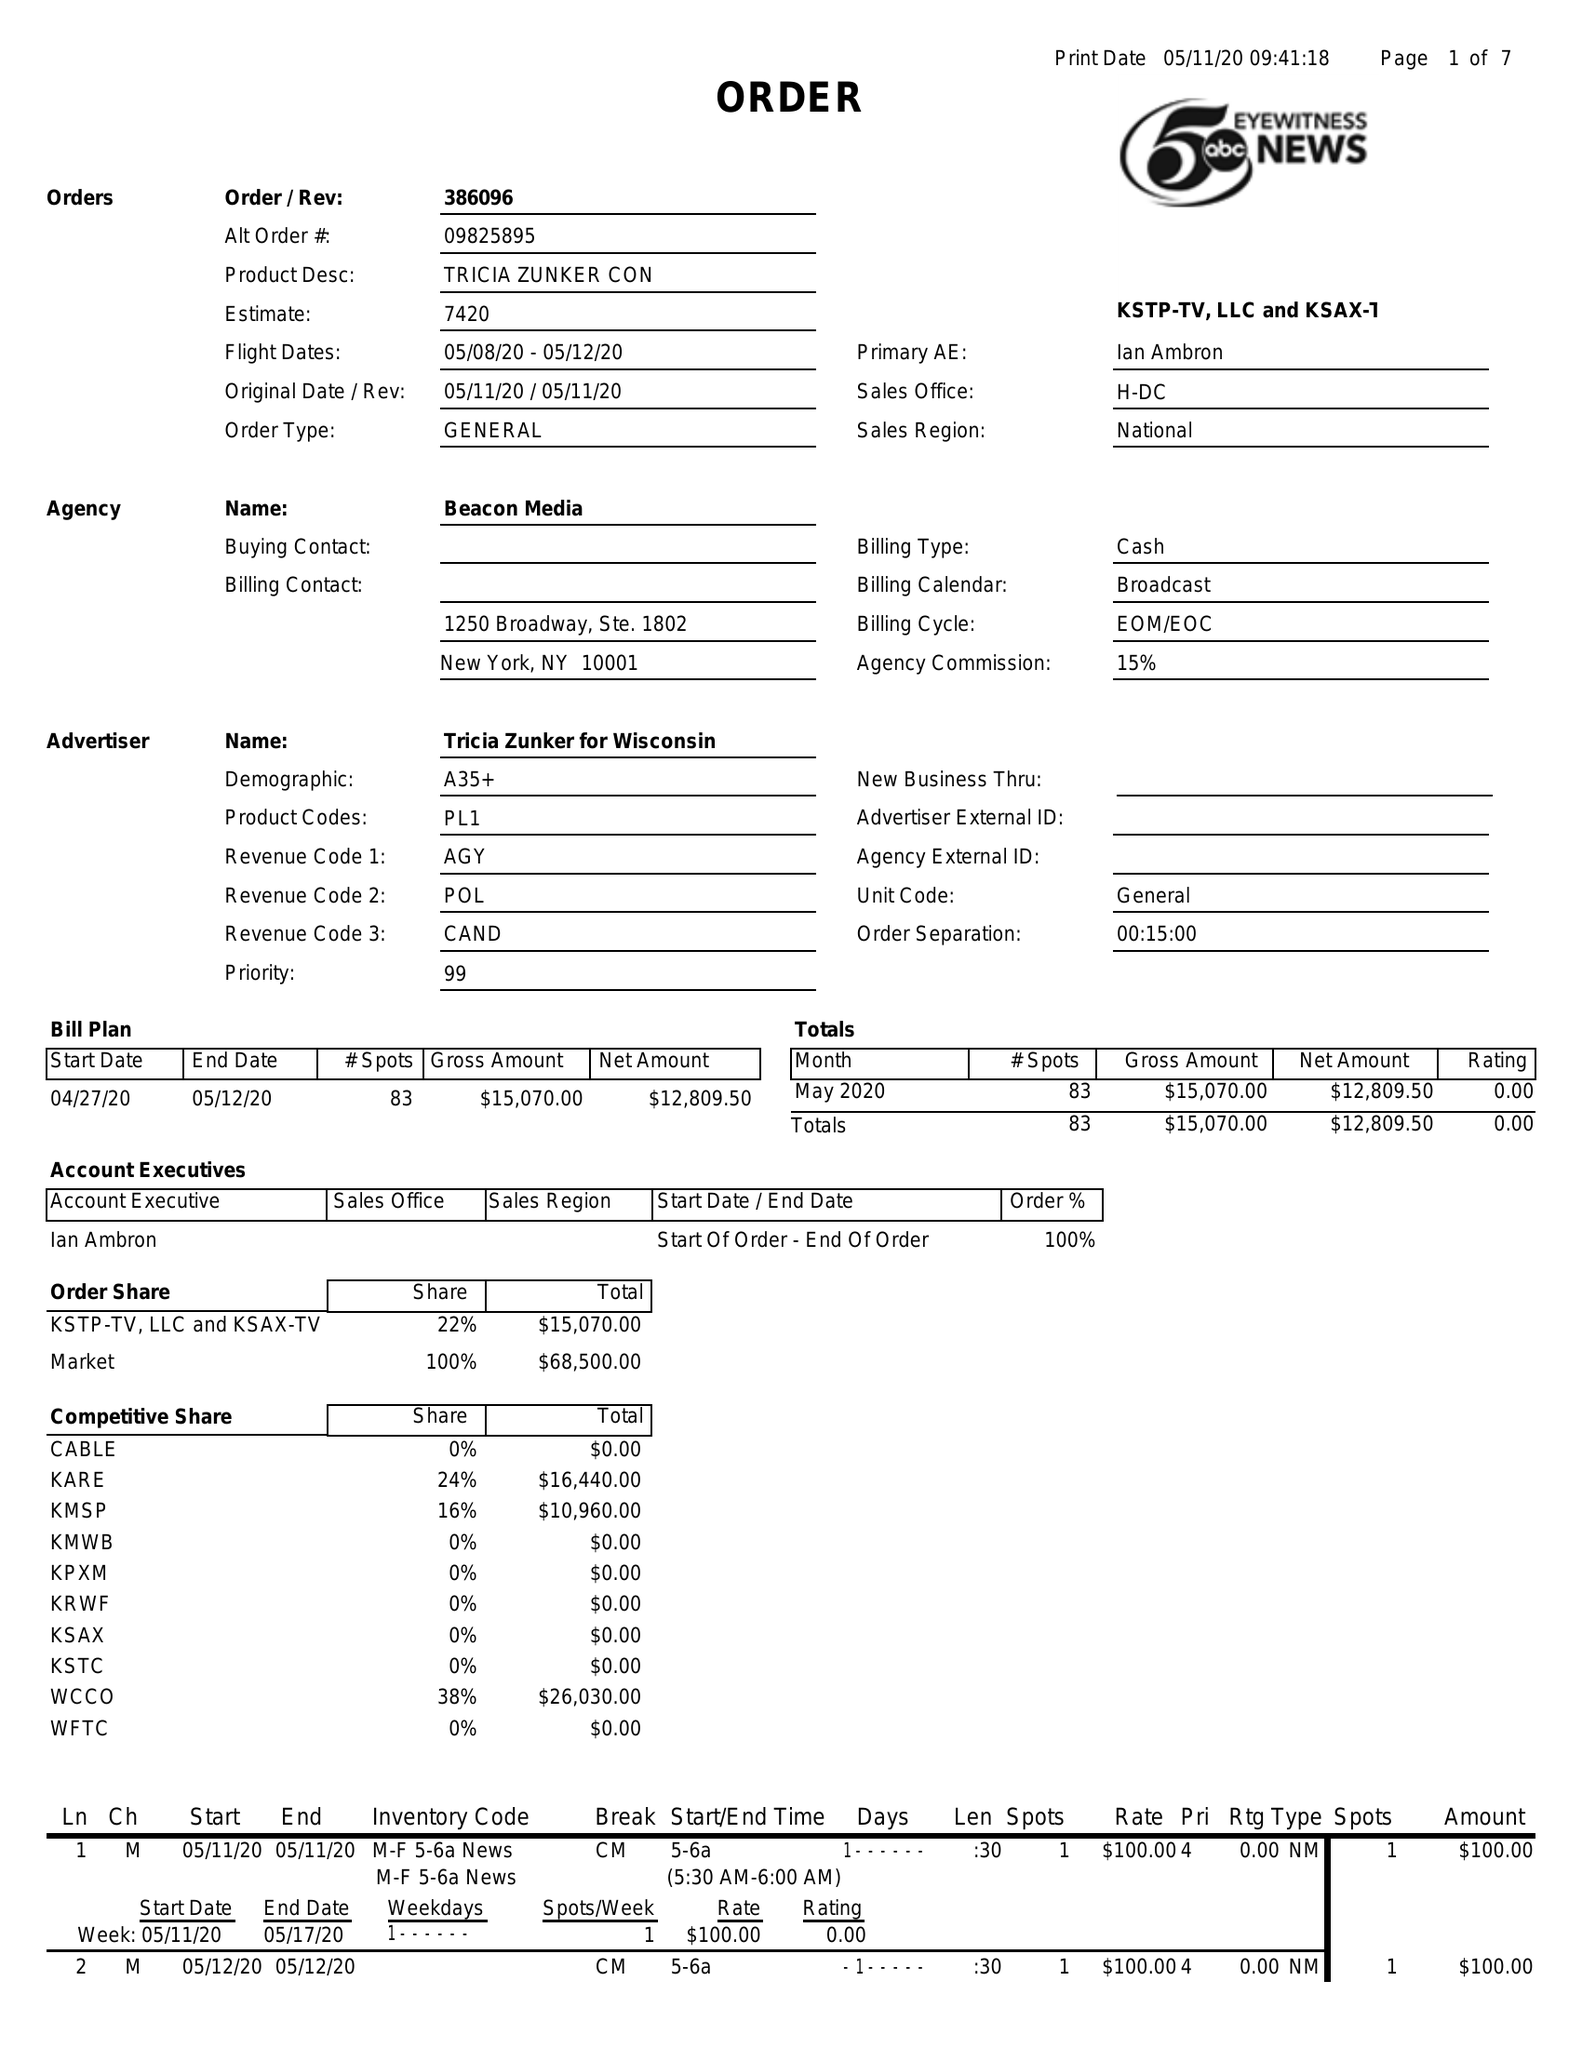What is the value for the contract_num?
Answer the question using a single word or phrase. 386096 